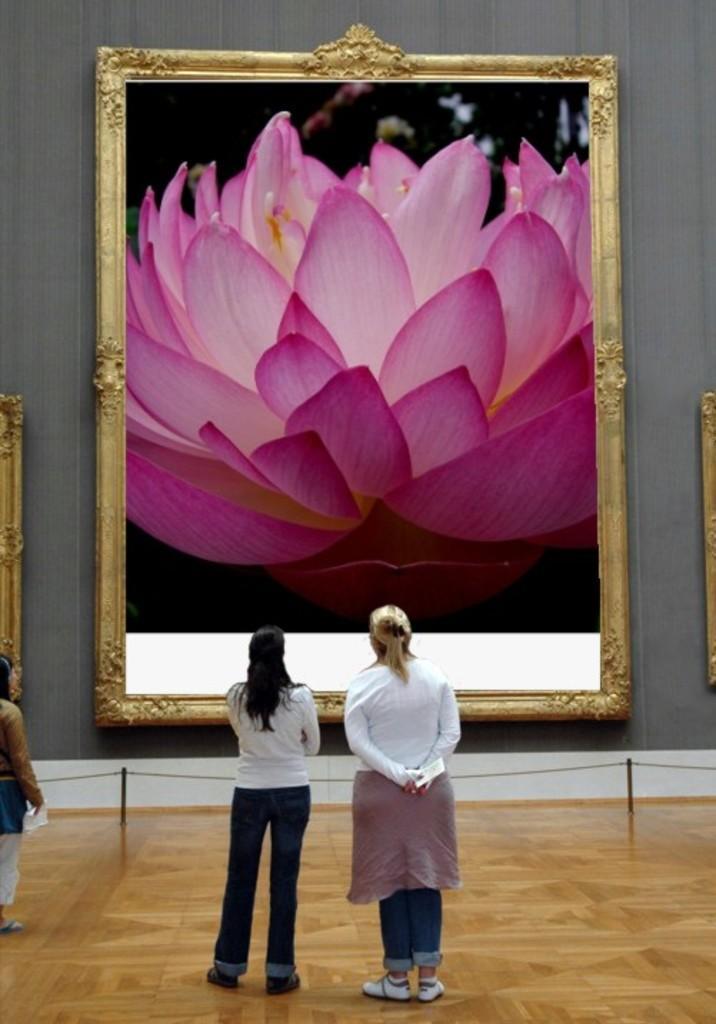Describe this image in one or two sentences. In this image few persons are standing on the floor. Before them there is a fence. Few frames are attached to the wall. On the frame there is a picture of a lotus flower. 